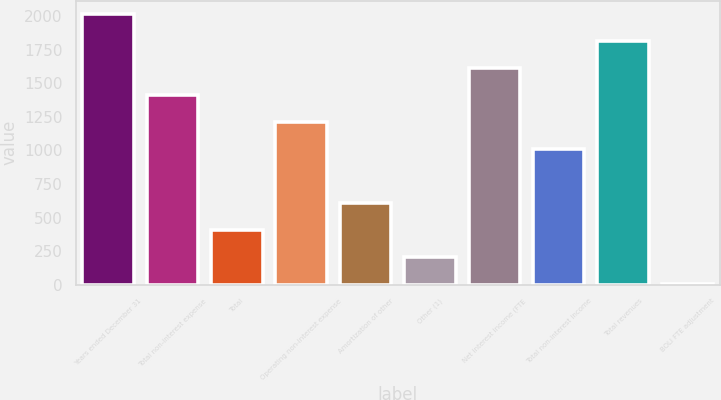<chart> <loc_0><loc_0><loc_500><loc_500><bar_chart><fcel>Years ended December 31<fcel>Total non-interest expense<fcel>Total<fcel>Operating non-interest expense<fcel>Amortization of other<fcel>Other (1)<fcel>Net interest income (FTE<fcel>Total non-interest income<fcel>Total revenues<fcel>BOLI FTE adjustment<nl><fcel>2013<fcel>1409.73<fcel>404.28<fcel>1208.64<fcel>605.37<fcel>203.19<fcel>1610.82<fcel>1007.55<fcel>1811.91<fcel>2.1<nl></chart> 